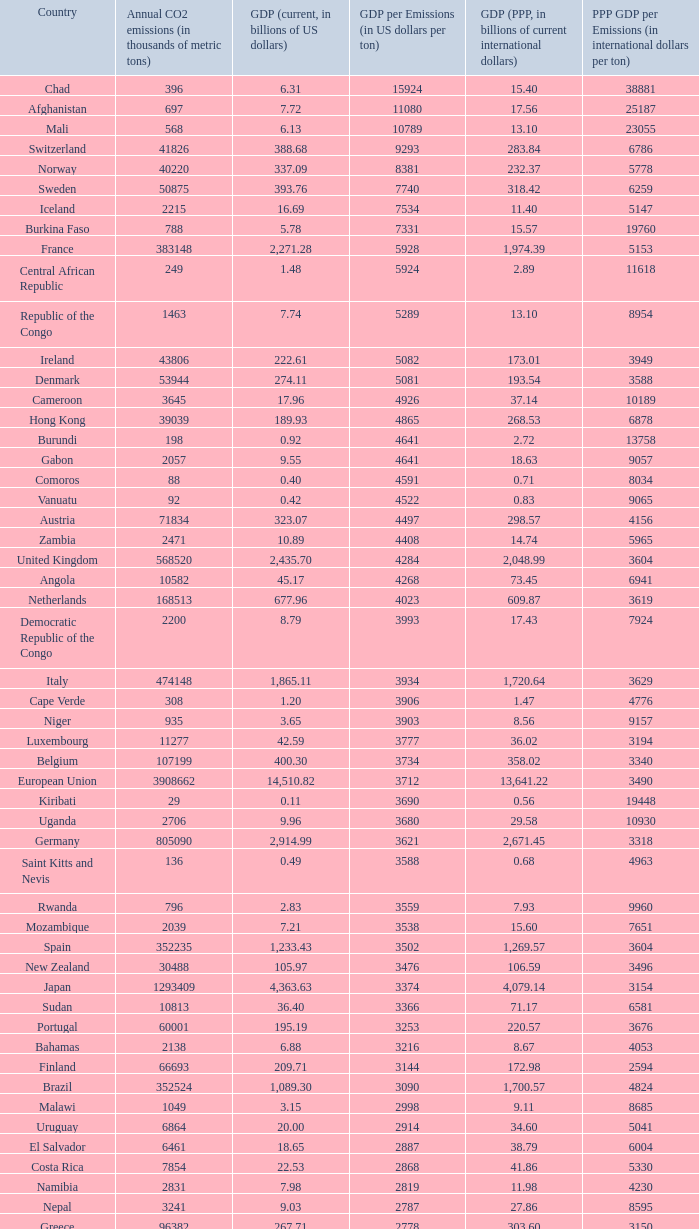For a country with 1811 thousand metric tons of co2 emissions per year, which country is it? Haiti. 